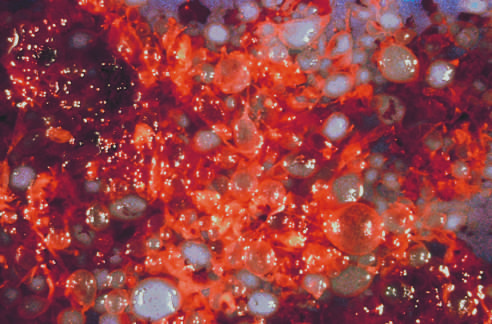does the cellular adaptation depicted here consist of numerous swollen villi?
Answer the question using a single word or phrase. No 